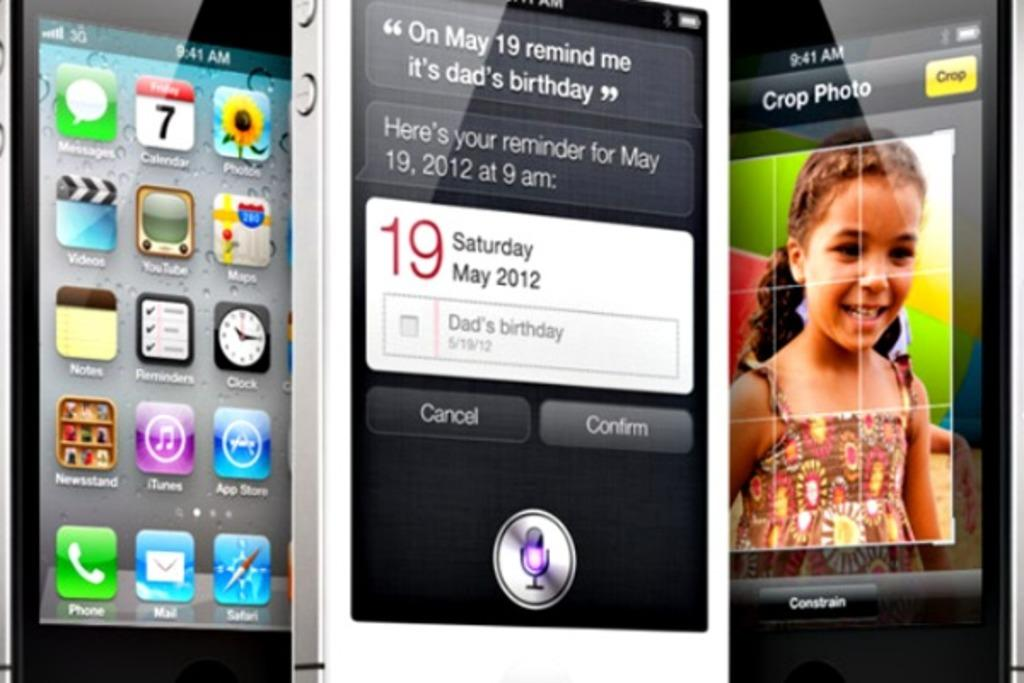<image>
Describe the image concisely. some phones with one that has the number 19 on it 